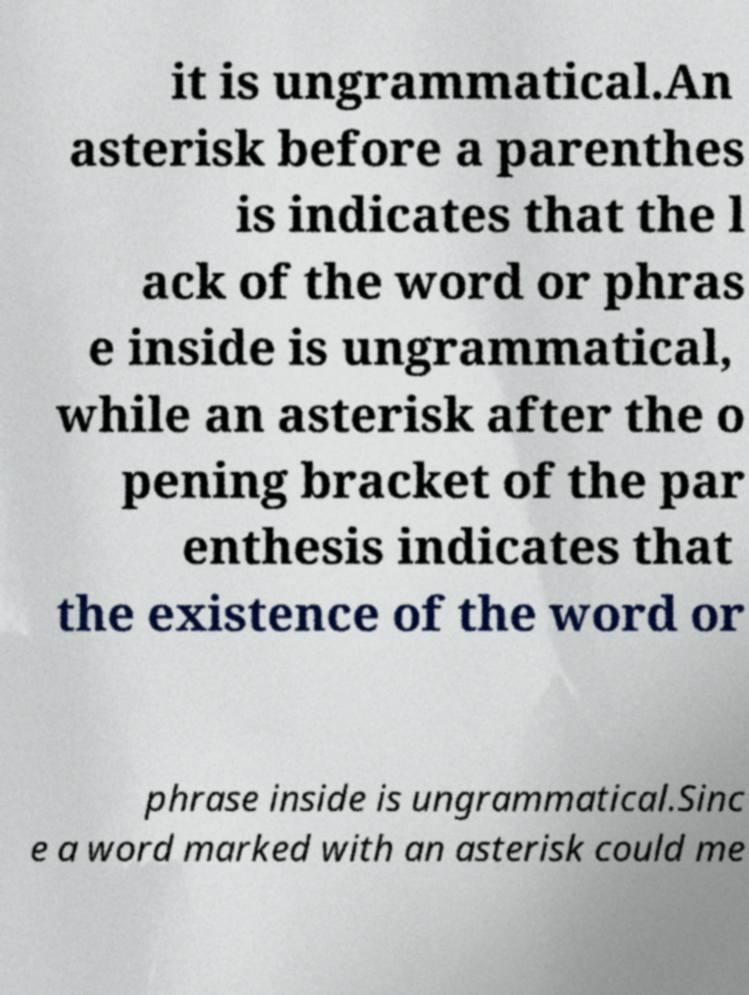Please identify and transcribe the text found in this image. it is ungrammatical.An asterisk before a parenthes is indicates that the l ack of the word or phras e inside is ungrammatical, while an asterisk after the o pening bracket of the par enthesis indicates that the existence of the word or phrase inside is ungrammatical.Sinc e a word marked with an asterisk could me 